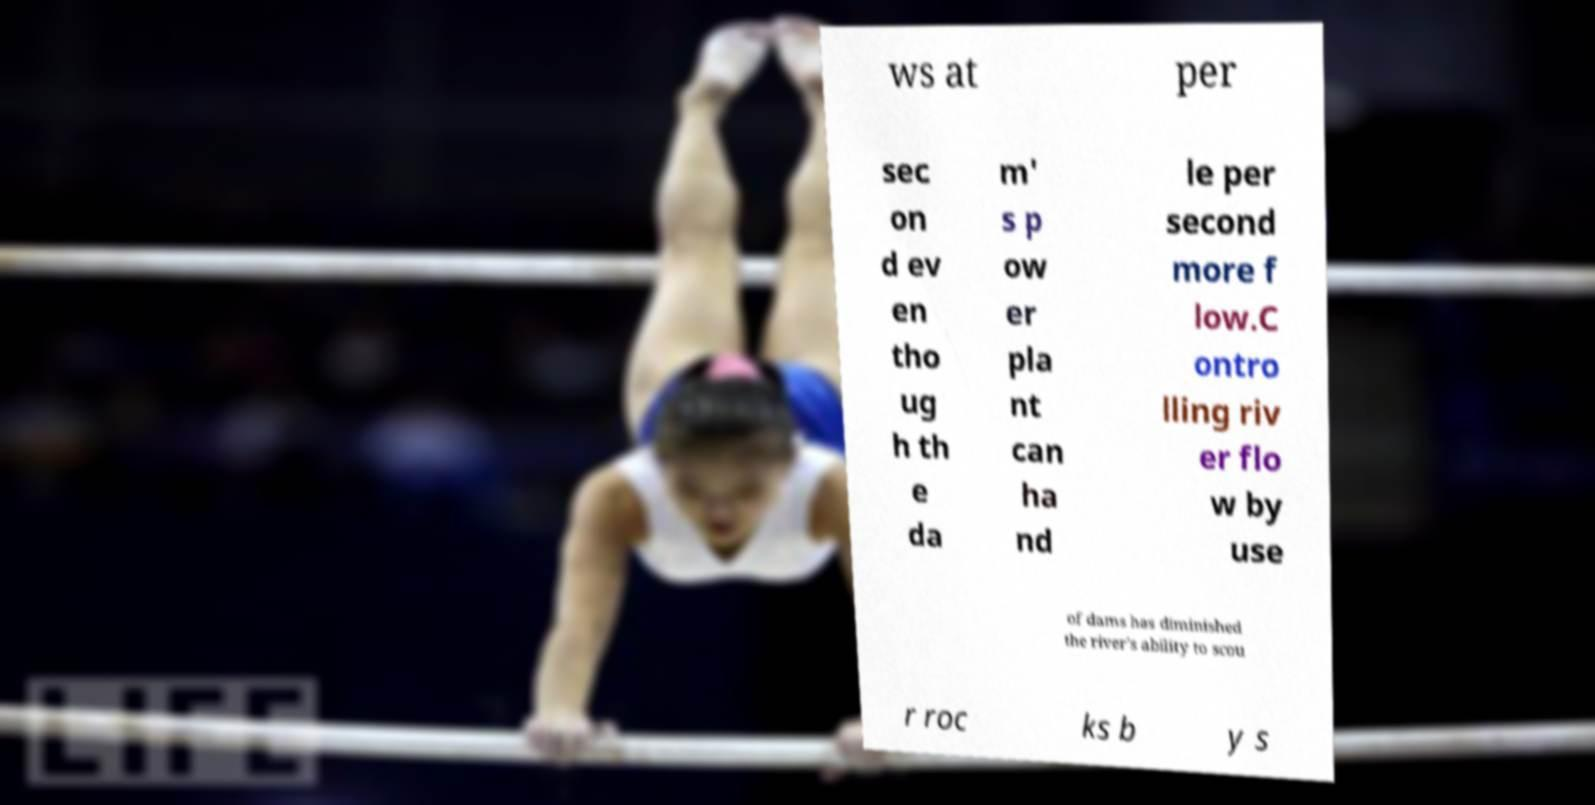I need the written content from this picture converted into text. Can you do that? ws at per sec on d ev en tho ug h th e da m' s p ow er pla nt can ha nd le per second more f low.C ontro lling riv er flo w by use of dams has diminished the river's ability to scou r roc ks b y s 